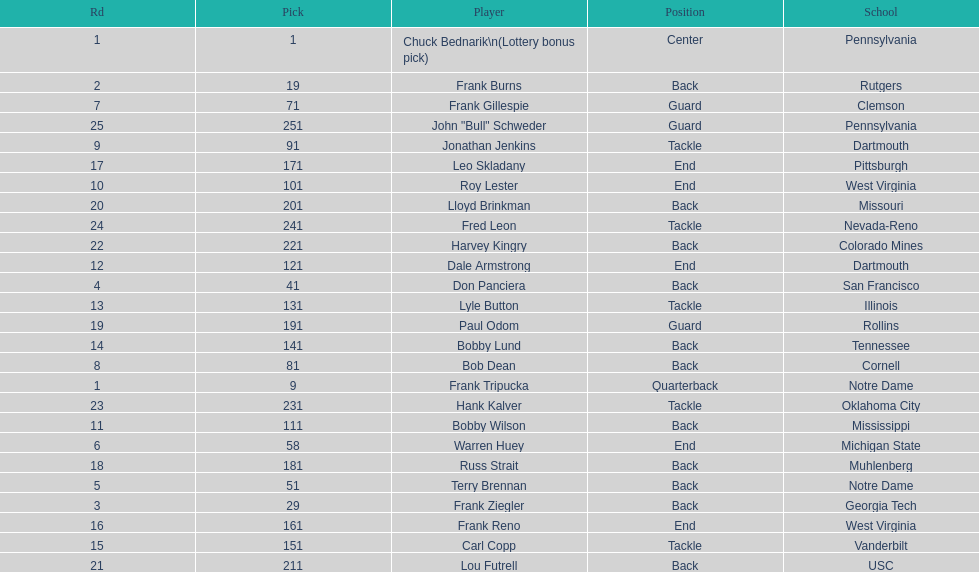What was the position that most of the players had? Back. 